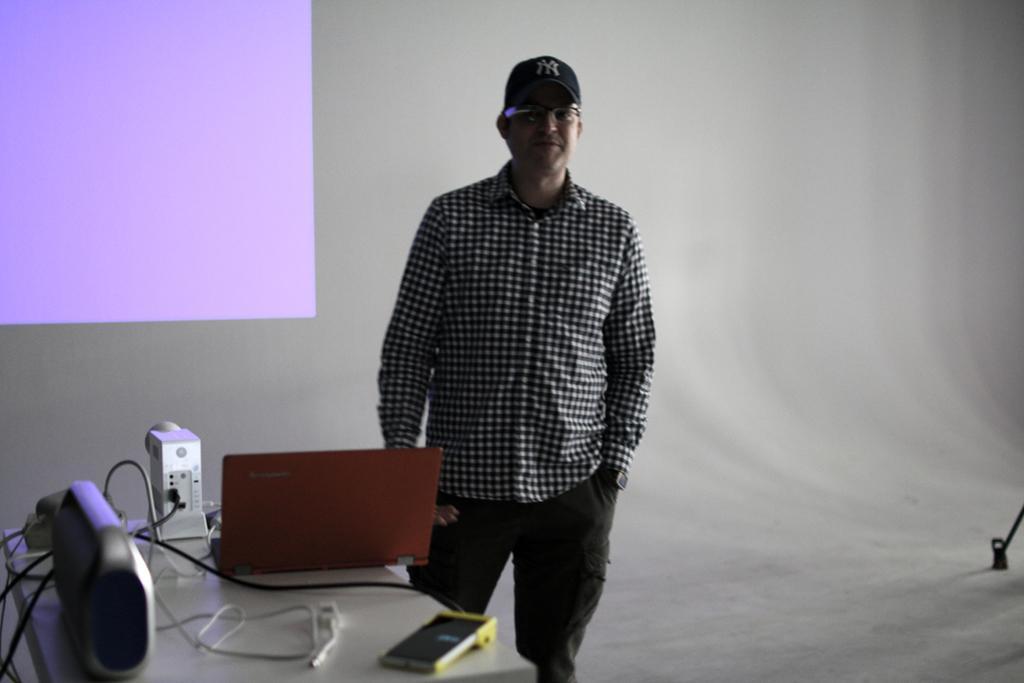In one or two sentences, can you explain what this image depicts? In the image,there is a man standing beside the table and on the table there are some gadgets and behind the man there is a purple screen. 